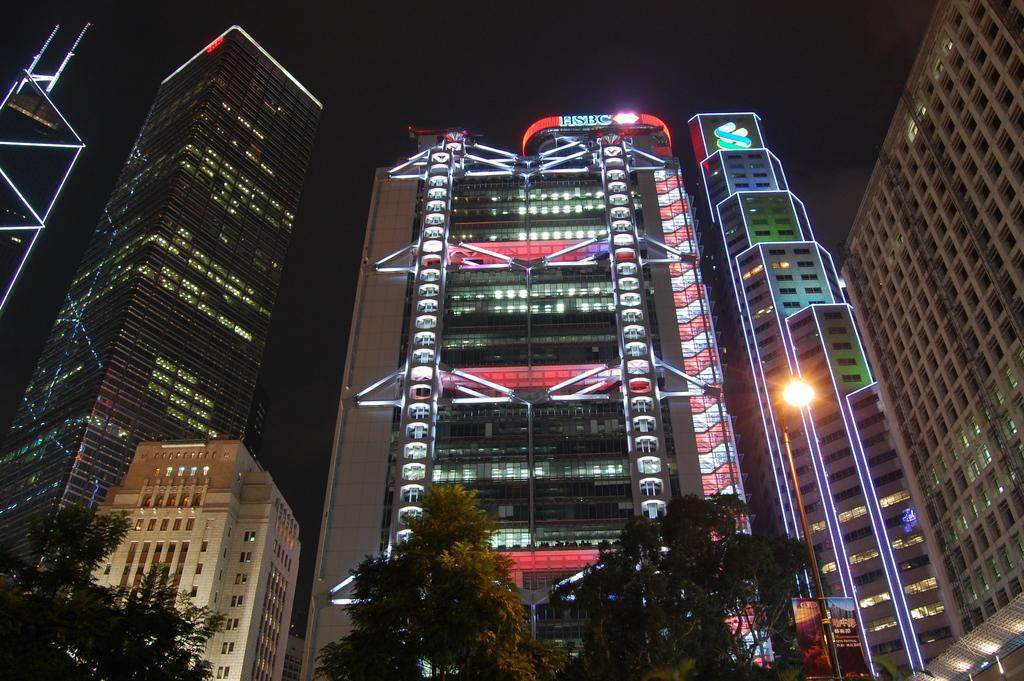What is located in the center of the image? There are buildings in the center of the image. What can be seen at the bottom of the image? There are trees at the bottom of the image. What is illuminated in the image? Lights are visible in the image. What is visible at the top of the image? The sky is visible at the top of the image. What type of class is being taught in the image? There is no class present in the image. Is there a ship visible in the image? No, there is no ship present in the image. 